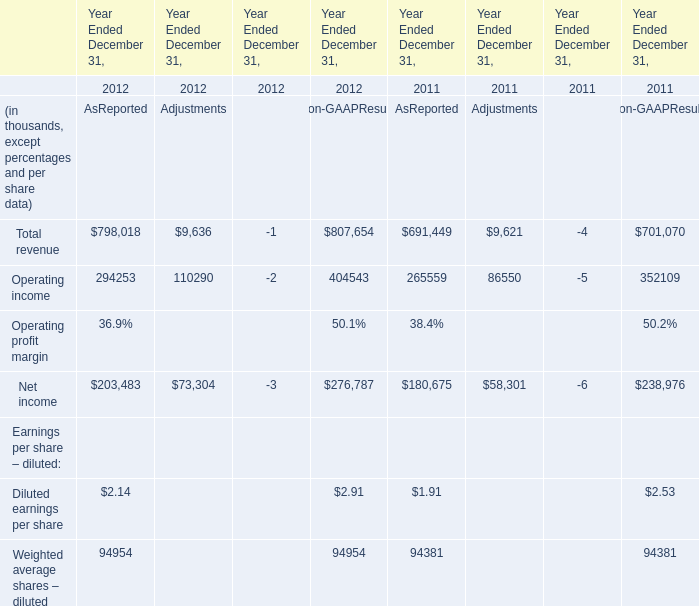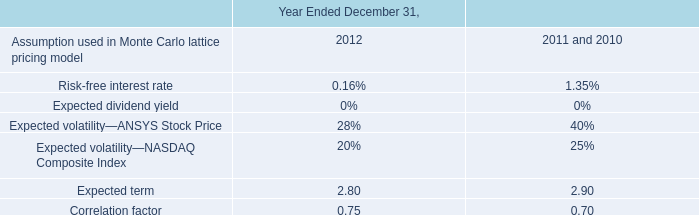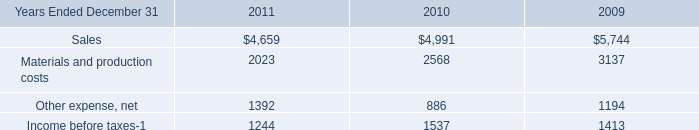What is the ratio of all AsReported that are smaller than 300000 to the sum of AsReported, in 2012? 
Computations: ((((294253 + 2.14) + 203483) + 94954) / ((((294253 + 2.14) + 203483) + 94954) + 798018))
Answer: 0.42618. 